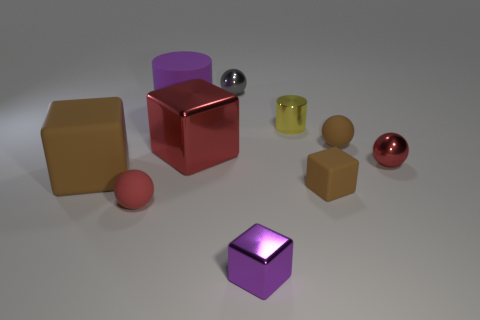Subtract all tiny red matte spheres. How many spheres are left? 3 Subtract all red blocks. How many blocks are left? 3 Subtract 1 cubes. How many cubes are left? 3 Subtract 0 green cylinders. How many objects are left? 10 Subtract all balls. How many objects are left? 6 Subtract all red cylinders. Subtract all cyan spheres. How many cylinders are left? 2 Subtract all red cylinders. How many brown cubes are left? 2 Subtract all purple matte objects. Subtract all brown balls. How many objects are left? 8 Add 1 red spheres. How many red spheres are left? 3 Add 7 red spheres. How many red spheres exist? 9 